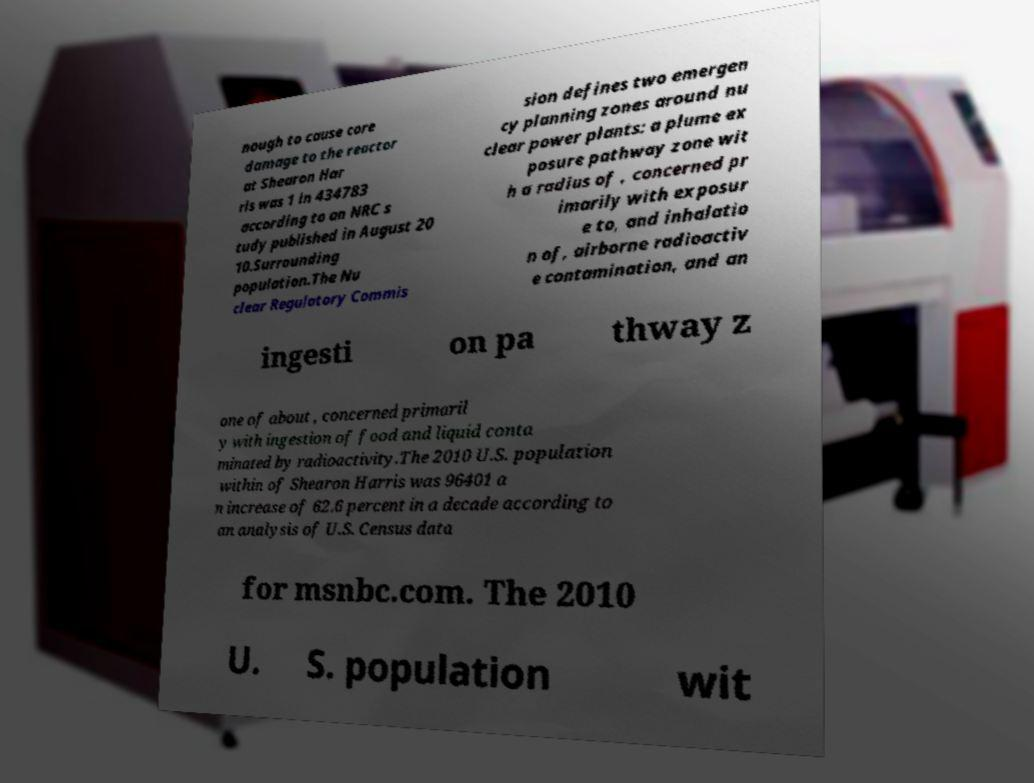There's text embedded in this image that I need extracted. Can you transcribe it verbatim? nough to cause core damage to the reactor at Shearon Har ris was 1 in 434783 according to an NRC s tudy published in August 20 10.Surrounding population.The Nu clear Regulatory Commis sion defines two emergen cy planning zones around nu clear power plants: a plume ex posure pathway zone wit h a radius of , concerned pr imarily with exposur e to, and inhalatio n of, airborne radioactiv e contamination, and an ingesti on pa thway z one of about , concerned primaril y with ingestion of food and liquid conta minated by radioactivity.The 2010 U.S. population within of Shearon Harris was 96401 a n increase of 62.6 percent in a decade according to an analysis of U.S. Census data for msnbc.com. The 2010 U. S. population wit 